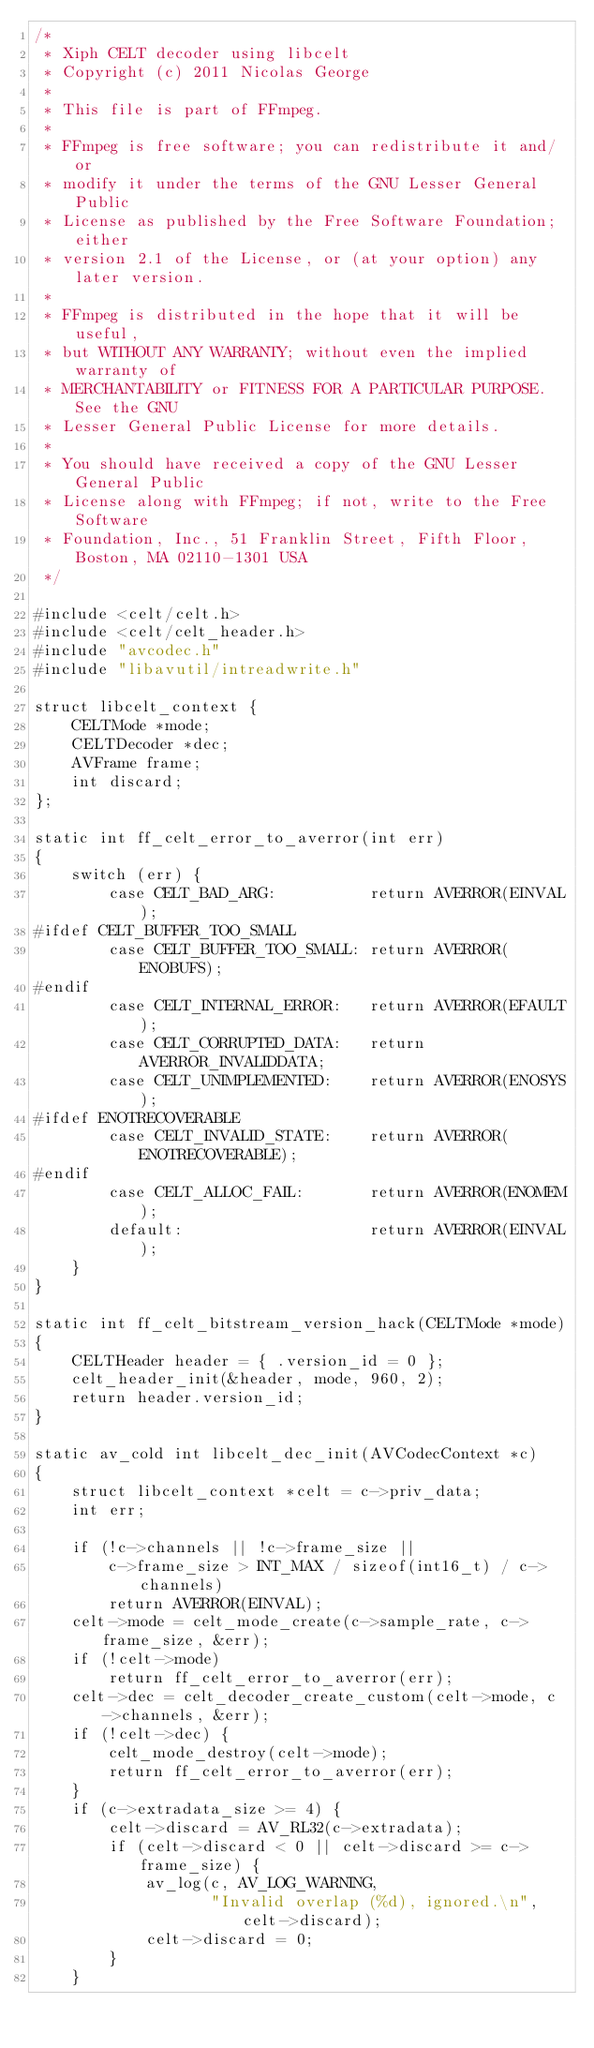<code> <loc_0><loc_0><loc_500><loc_500><_C_>/*
 * Xiph CELT decoder using libcelt
 * Copyright (c) 2011 Nicolas George
 *
 * This file is part of FFmpeg.
 *
 * FFmpeg is free software; you can redistribute it and/or
 * modify it under the terms of the GNU Lesser General Public
 * License as published by the Free Software Foundation; either
 * version 2.1 of the License, or (at your option) any later version.
 *
 * FFmpeg is distributed in the hope that it will be useful,
 * but WITHOUT ANY WARRANTY; without even the implied warranty of
 * MERCHANTABILITY or FITNESS FOR A PARTICULAR PURPOSE.  See the GNU
 * Lesser General Public License for more details.
 *
 * You should have received a copy of the GNU Lesser General Public
 * License along with FFmpeg; if not, write to the Free Software
 * Foundation, Inc., 51 Franklin Street, Fifth Floor, Boston, MA 02110-1301 USA
 */

#include <celt/celt.h>
#include <celt/celt_header.h>
#include "avcodec.h"
#include "libavutil/intreadwrite.h"

struct libcelt_context {
    CELTMode *mode;
    CELTDecoder *dec;
    AVFrame frame;
    int discard;
};

static int ff_celt_error_to_averror(int err)
{
    switch (err) {
        case CELT_BAD_ARG:          return AVERROR(EINVAL);
#ifdef CELT_BUFFER_TOO_SMALL
        case CELT_BUFFER_TOO_SMALL: return AVERROR(ENOBUFS);
#endif
        case CELT_INTERNAL_ERROR:   return AVERROR(EFAULT);
        case CELT_CORRUPTED_DATA:   return AVERROR_INVALIDDATA;
        case CELT_UNIMPLEMENTED:    return AVERROR(ENOSYS);
#ifdef ENOTRECOVERABLE
        case CELT_INVALID_STATE:    return AVERROR(ENOTRECOVERABLE);
#endif
        case CELT_ALLOC_FAIL:       return AVERROR(ENOMEM);
        default:                    return AVERROR(EINVAL);
    }
}

static int ff_celt_bitstream_version_hack(CELTMode *mode)
{
    CELTHeader header = { .version_id = 0 };
    celt_header_init(&header, mode, 960, 2);
    return header.version_id;
}

static av_cold int libcelt_dec_init(AVCodecContext *c)
{
    struct libcelt_context *celt = c->priv_data;
    int err;

    if (!c->channels || !c->frame_size ||
        c->frame_size > INT_MAX / sizeof(int16_t) / c->channels)
        return AVERROR(EINVAL);
    celt->mode = celt_mode_create(c->sample_rate, c->frame_size, &err);
    if (!celt->mode)
        return ff_celt_error_to_averror(err);
    celt->dec = celt_decoder_create_custom(celt->mode, c->channels, &err);
    if (!celt->dec) {
        celt_mode_destroy(celt->mode);
        return ff_celt_error_to_averror(err);
    }
    if (c->extradata_size >= 4) {
        celt->discard = AV_RL32(c->extradata);
        if (celt->discard < 0 || celt->discard >= c->frame_size) {
            av_log(c, AV_LOG_WARNING,
                   "Invalid overlap (%d), ignored.\n", celt->discard);
            celt->discard = 0;
        }
    }</code> 